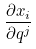<formula> <loc_0><loc_0><loc_500><loc_500>\frac { \partial x _ { i } } { \partial q ^ { j } }</formula> 